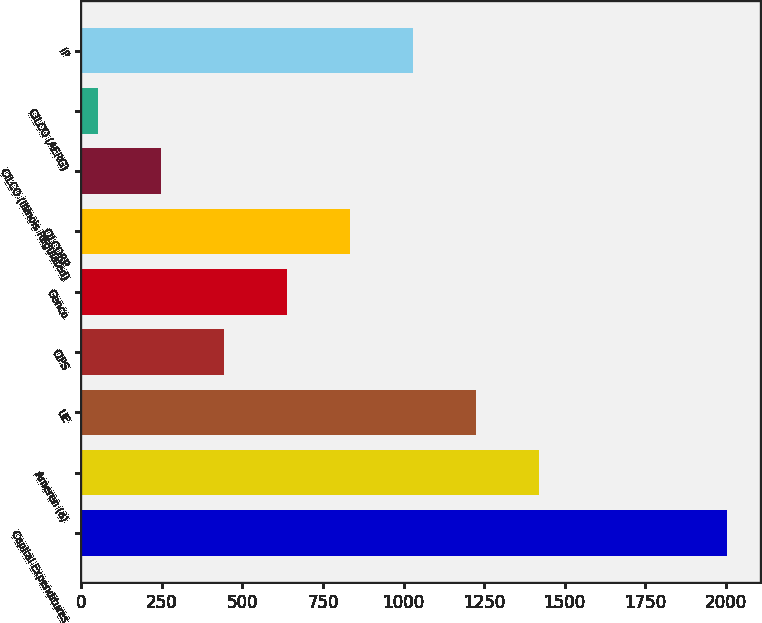Convert chart. <chart><loc_0><loc_0><loc_500><loc_500><bar_chart><fcel>Capital Expenditures<fcel>Ameren (a)<fcel>UE<fcel>CIPS<fcel>Genco<fcel>CILCORP<fcel>CILCO (Illinois Regulated)<fcel>CILCO (AERG)<fcel>IP<nl><fcel>2005<fcel>1419.1<fcel>1223.8<fcel>442.6<fcel>637.9<fcel>833.2<fcel>247.3<fcel>52<fcel>1028.5<nl></chart> 